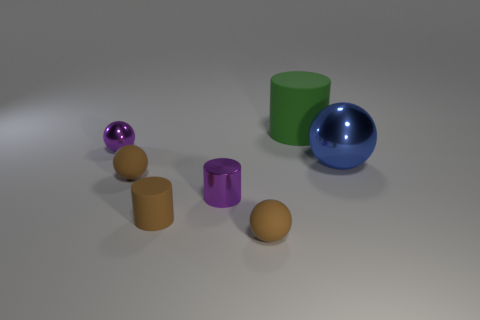How many brown spheres must be subtracted to get 1 brown spheres? 1 Subtract all gray balls. Subtract all red cubes. How many balls are left? 4 Add 1 big purple balls. How many objects exist? 8 Subtract all cylinders. How many objects are left? 4 Add 6 big cylinders. How many big cylinders exist? 7 Subtract 0 cyan blocks. How many objects are left? 7 Subtract all blue cylinders. Subtract all matte things. How many objects are left? 3 Add 2 blue things. How many blue things are left? 3 